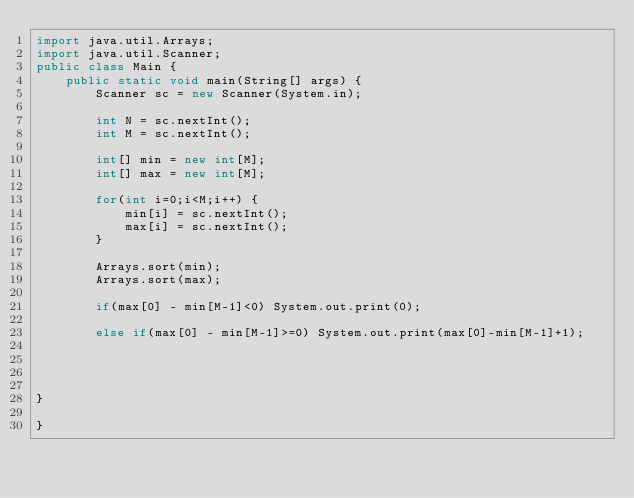<code> <loc_0><loc_0><loc_500><loc_500><_Java_>import java.util.Arrays;
import java.util.Scanner;
public class Main {
	public static void main(String[] args) {
		Scanner sc = new Scanner(System.in);

		int N = sc.nextInt();
		int M = sc.nextInt();

		int[] min = new int[M];
		int[] max = new int[M];

		for(int i=0;i<M;i++) {
			min[i] = sc.nextInt();
			max[i] = sc.nextInt();
		}

		Arrays.sort(min);
		Arrays.sort(max);

		if(max[0] - min[M-1]<0) System.out.print(0);

		else if(max[0] - min[M-1]>=0) System.out.print(max[0]-min[M-1]+1);




}

}</code> 